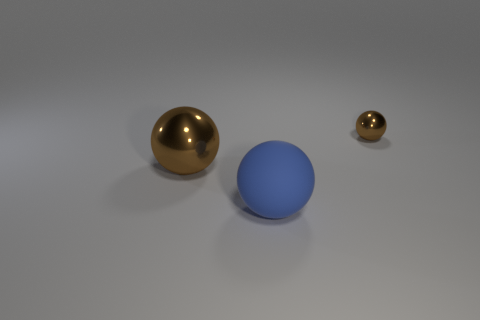What could the different sizes of spheres represent? The varying sizes of the spheres could symbolize a range of concepts, such as planets in a solar system, balls used in various sports, or even a visual representation of hierarchical relationships or scales. 